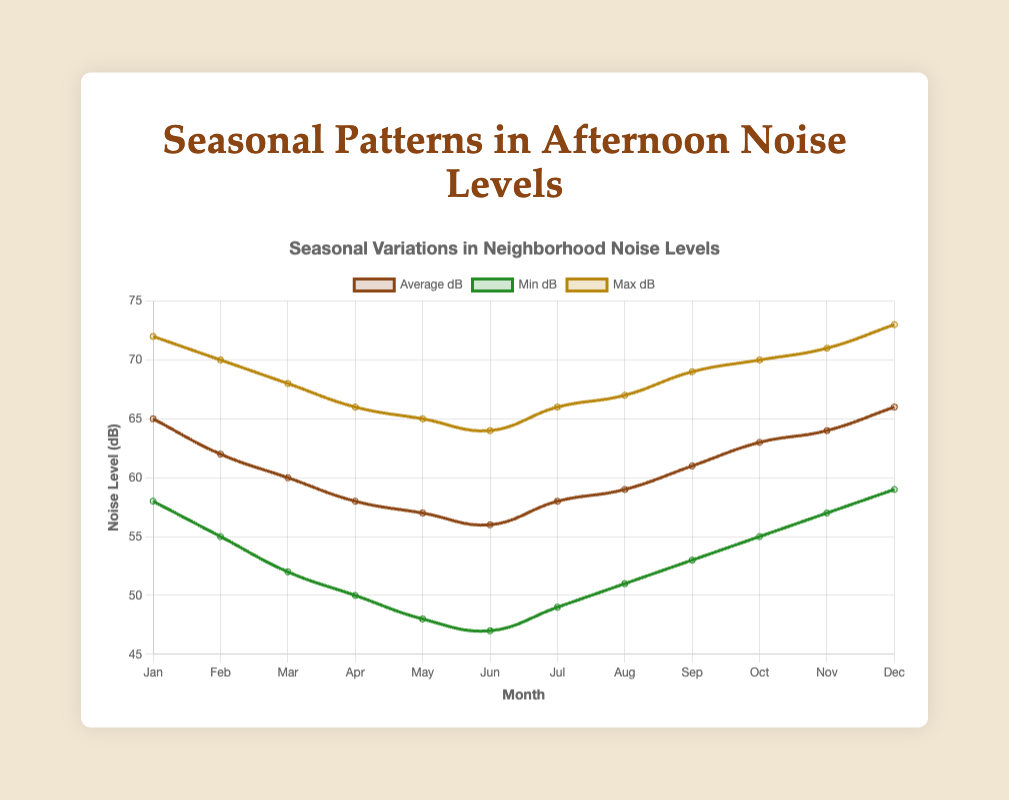What is the average noise level in April? Look for the data point corresponding to April and refer to the value for average dB. The value is clearly labeled.
Answer: 58 dB Which month has the lowest minimum noise level? Examine the "Min dB" line and find the lowest point across all months. The lowest value is 47 dB, which corresponds to June.
Answer: June What's the difference between the maximum noise levels in January and July? Find the maximum dB levels for both January (72 dB) and July (66 dB). Then calculate the difference: 72 - 66.
Answer: 6 dB How do the noise levels in February compare to those in October? Compare the average dB value for February (62 dB) and October (63 dB). October has a slightly higher average dB.
Answer: October is higher What is the range of noise levels in December? The range is calculated as max dB minus min dB for December. Look at the chart for December: max dB = 73, min dB = 59. So, 73 - 59.
Answer: 14 dB Which season experiences the highest average noise levels? Calculate the average noise levels by season: 
- Winter (Dec, Jan, Feb): (66 + 65 + 62) / 3 = 64.33
- Spring (Mar, Apr, May): (60 + 58 + 57) / 3 = 58.33
- Summer (Jun, Jul, Aug): (56 + 58 + 59) / 3 = 57.67
- Fall (Sep, Oct, Nov): (61 + 63 + 64) / 3 = 62.67
Winter has the highest average.
Answer: Winter In which month does the average noise level first drop below 60 dB? Check each month's average dB in descending order until it is below 60 dB. It first drops in March (60 dB). Next month is April (58 dB).
Answer: April How much does the average noise level change from the quietest to the loudest month? Identify the quietest month (June, 56 dB) and the loudest month (December, 66 dB). Then compute the change: 66 - 56.
Answer: 10 dB Which month's noise levels have the largest variation between minimum and maximum? Calculate the variation (max dB - min dB) for each month and find the largest:
- January: 72 - 58 = 14
- February: 70 - 55 = 15
- March: 68 - 52 = 16
- April: 66 - 50 = 16
- May: 65 - 48 = 17
- June: 64 - 47 = 17
- July: 66 - 49 = 17
- August: 67 - 51 = 16
- September: 69 - 53 = 16
- October: 70 - 55 = 15
- November: 71 - 57 = 14
- December: 73 - 59 = 14
May, June, and July have the largest variation of 17 dB.
Answer: May, June, and July What is the trend in average noise levels from January to December? Look at the average dB values plotted on the chart from January to December: 65, 62, 60, 58, 57, 56, 58, 59, 61, 63, 64, 66. It generally decreases first and then increases after June.
Answer: Decreases then increases 